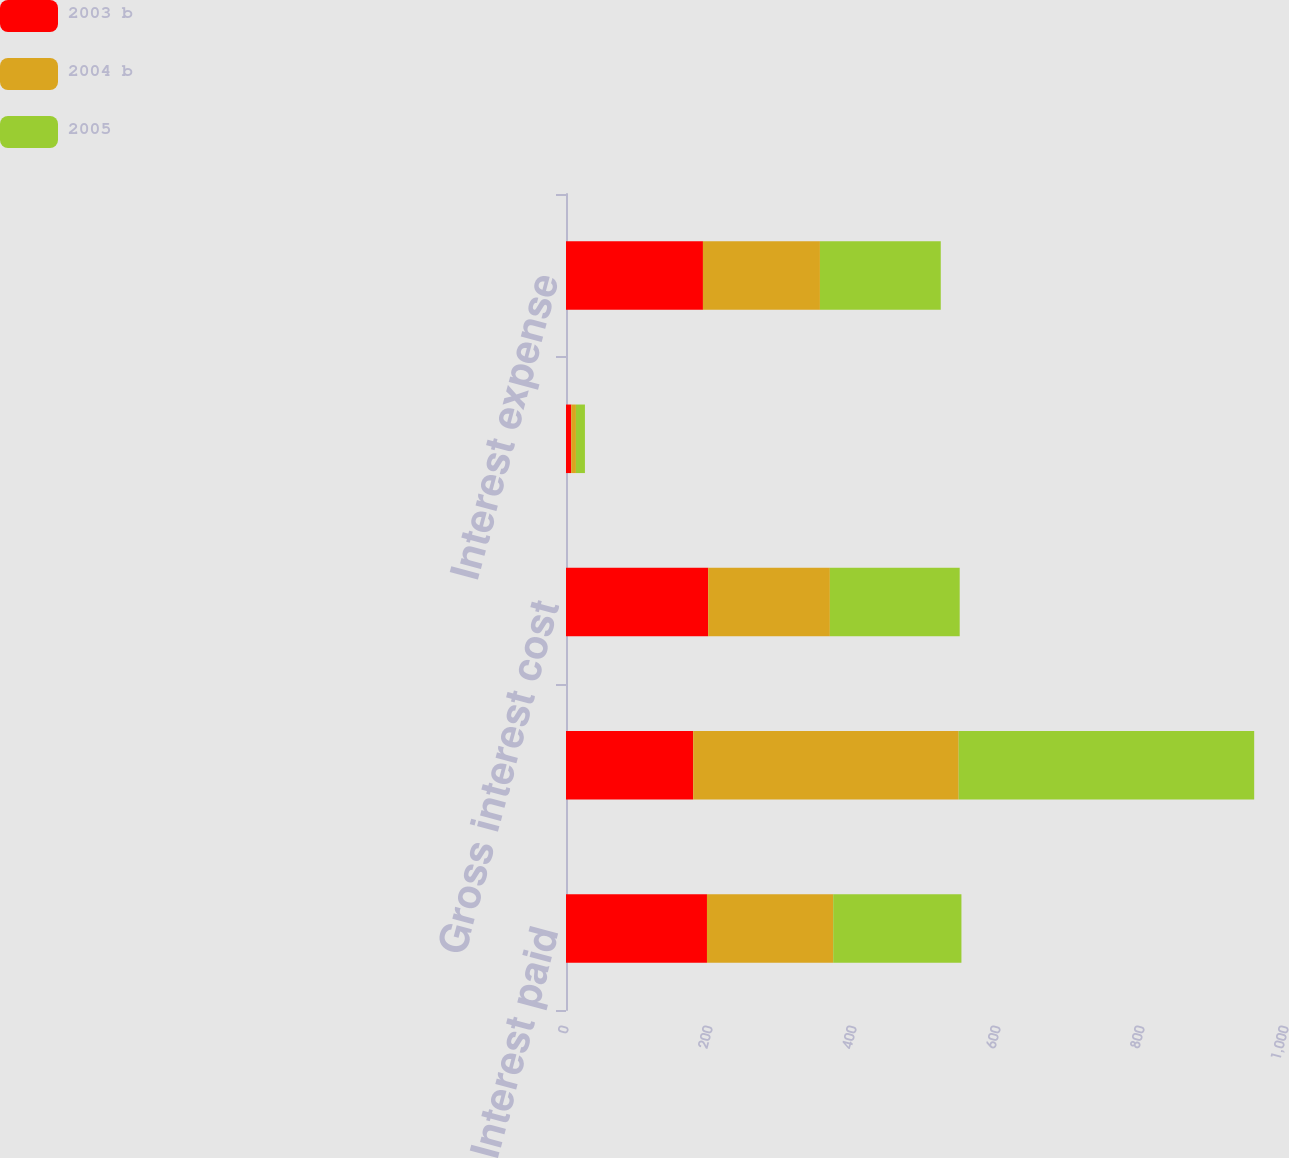Convert chart to OTSL. <chart><loc_0><loc_0><loc_500><loc_500><stacked_bar_chart><ecel><fcel>Interest paid<fcel>Income taxes paid<fcel>Gross interest cost<fcel>Capitalized interest on major<fcel>Interest expense<nl><fcel>2003 b<fcel>195.8<fcel>176.7<fcel>197.5<fcel>7.3<fcel>190.2<nl><fcel>2004 b<fcel>175.3<fcel>368.7<fcel>169<fcel>6.5<fcel>162.5<nl><fcel>2005<fcel>178.1<fcel>410.4<fcel>180.3<fcel>12.5<fcel>167.8<nl></chart> 